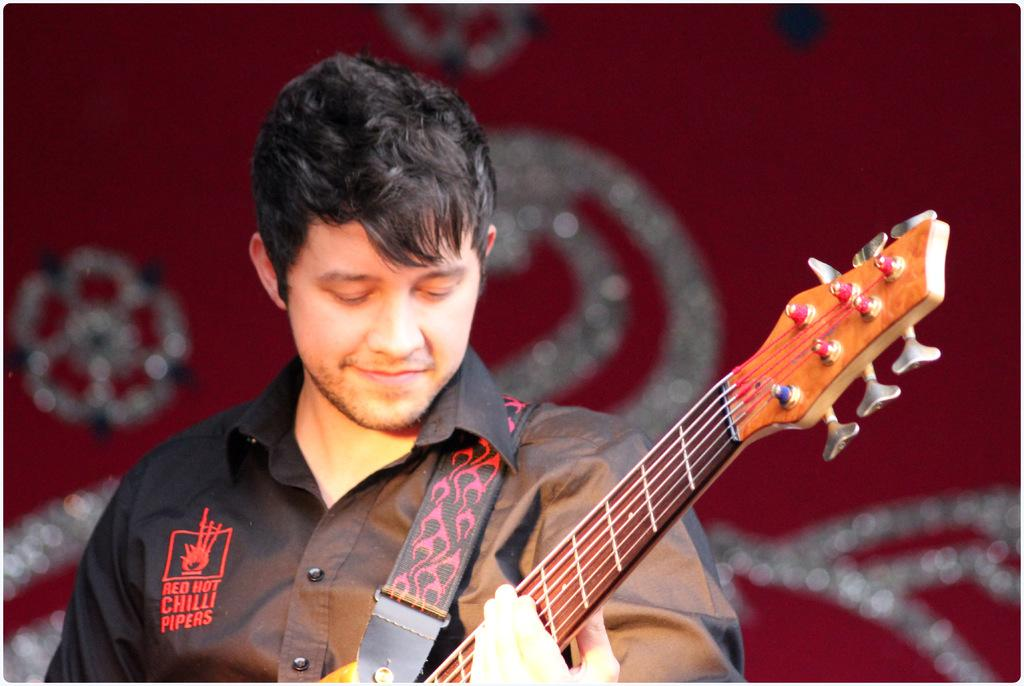Who is the main subject in the image? There is a man in the image. What is the man wearing? The man is wearing a black shirt. What is the man holding in the image? The man is holding a guitar. What can be seen behind the man? There is a curtain behind the man. How many sons does the man have in the image? There is no information about the man's sons in the image. Is the man riding a bike in the image? There is no bike present in the image. 